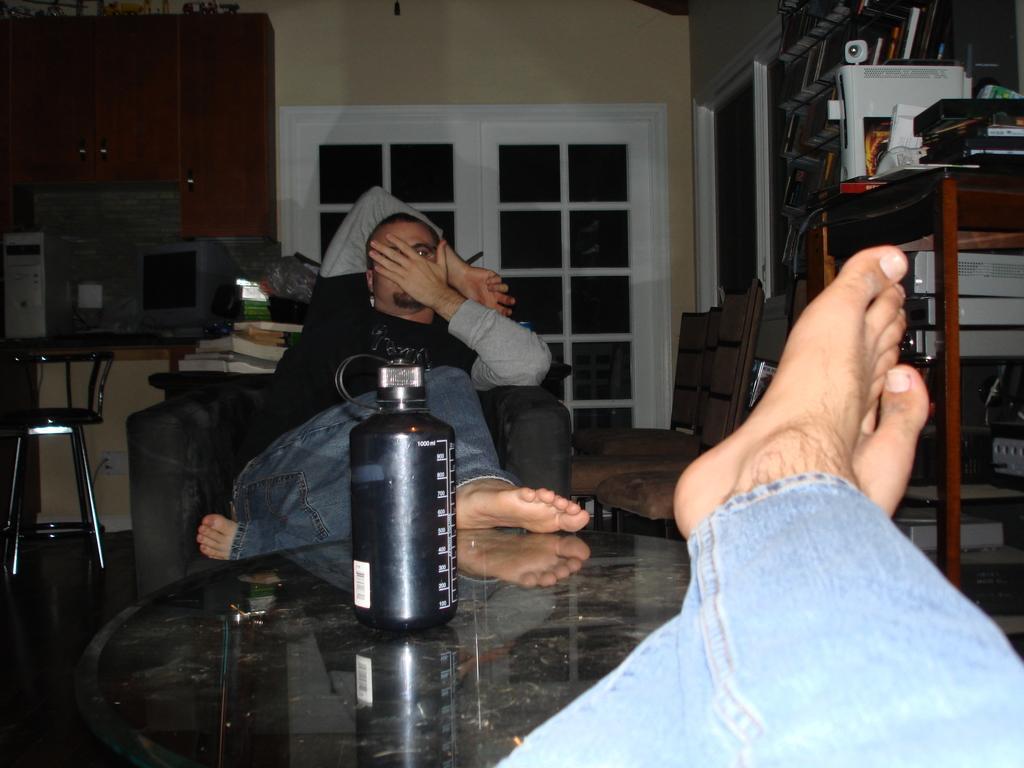Describe this image in one or two sentences. On the background we can see a wall, cupboard and a door. Here we can see two persons sitting on a chair in front of a table and on the table we can see a bottle. This is also a chair. here on the table we can see a computer. At the right side of the picture we can see a table and few items on the table. 